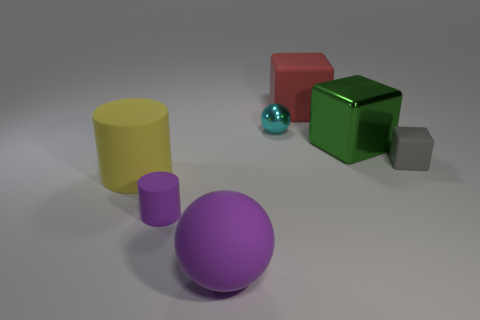Is there anything else that is the same color as the large rubber cube?
Your answer should be very brief. No. What is the color of the ball that is the same material as the gray object?
Ensure brevity in your answer.  Purple. How many purple spheres have the same material as the tiny gray object?
Provide a succinct answer. 1. Are there an equal number of small gray things to the left of the big purple rubber object and large cylinders that are behind the green block?
Provide a short and direct response. Yes. There is a green metallic object; is its shape the same as the purple rubber thing that is left of the big purple matte thing?
Offer a very short reply. No. What is the material of the small cylinder that is the same color as the matte ball?
Ensure brevity in your answer.  Rubber. Are there any other things that have the same shape as the big green shiny object?
Provide a short and direct response. Yes. Are the large purple ball and the big thing that is behind the metallic block made of the same material?
Your answer should be compact. Yes. What is the color of the big rubber object that is in front of the matte cylinder that is to the left of the small object in front of the small gray thing?
Provide a succinct answer. Purple. Is there anything else that is the same size as the red matte block?
Give a very brief answer. Yes. 